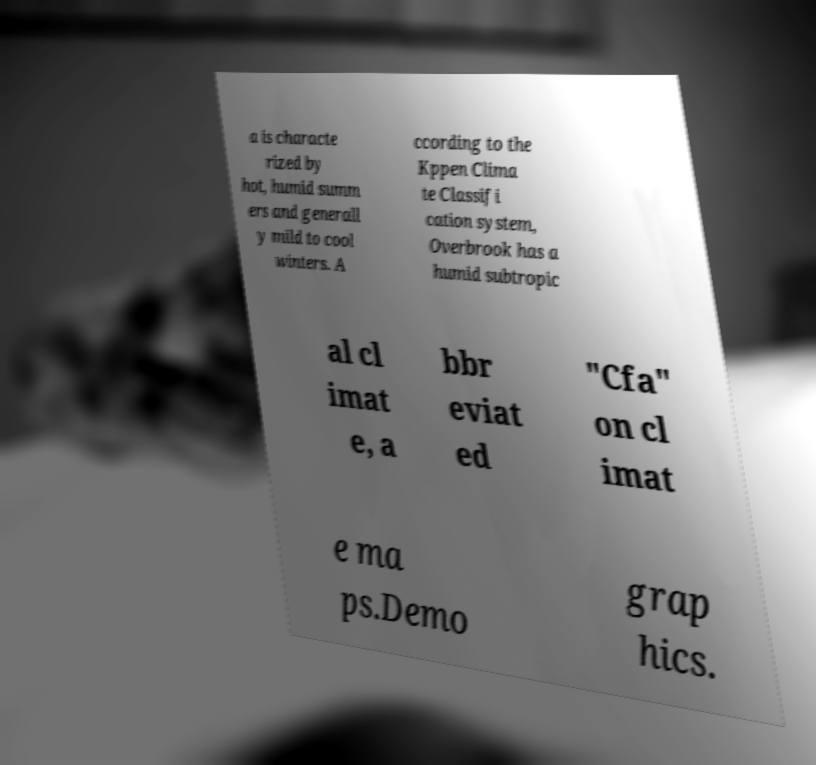Could you extract and type out the text from this image? a is characte rized by hot, humid summ ers and generall y mild to cool winters. A ccording to the Kppen Clima te Classifi cation system, Overbrook has a humid subtropic al cl imat e, a bbr eviat ed "Cfa" on cl imat e ma ps.Demo grap hics. 